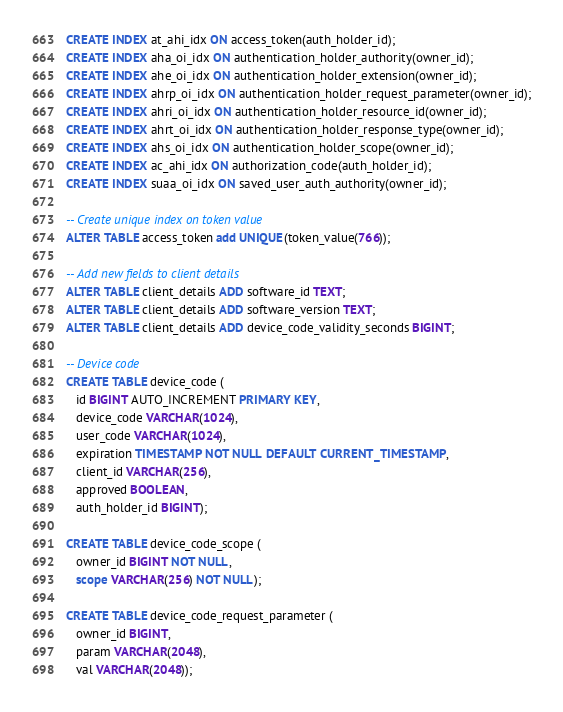Convert code to text. <code><loc_0><loc_0><loc_500><loc_500><_SQL_>CREATE INDEX at_ahi_idx ON access_token(auth_holder_id);
CREATE INDEX aha_oi_idx ON authentication_holder_authority(owner_id);
CREATE INDEX ahe_oi_idx ON authentication_holder_extension(owner_id);
CREATE INDEX ahrp_oi_idx ON authentication_holder_request_parameter(owner_id);
CREATE INDEX ahri_oi_idx ON authentication_holder_resource_id(owner_id);
CREATE INDEX ahrt_oi_idx ON authentication_holder_response_type(owner_id);
CREATE INDEX ahs_oi_idx ON authentication_holder_scope(owner_id);
CREATE INDEX ac_ahi_idx ON authorization_code(auth_holder_id);
CREATE INDEX suaa_oi_idx ON saved_user_auth_authority(owner_id);

-- Create unique index on token value
ALTER TABLE access_token add UNIQUE(token_value(766));

-- Add new fields to client details
ALTER TABLE client_details ADD software_id TEXT;
ALTER TABLE client_details ADD software_version TEXT;
ALTER TABLE client_details ADD device_code_validity_seconds BIGINT;

-- Device code
CREATE TABLE device_code (
   id BIGINT AUTO_INCREMENT PRIMARY KEY,
   device_code VARCHAR(1024),
   user_code VARCHAR(1024),
   expiration TIMESTAMP NOT NULL DEFAULT CURRENT_TIMESTAMP,
   client_id VARCHAR(256),
   approved BOOLEAN,
   auth_holder_id BIGINT);
   
CREATE TABLE device_code_scope (
   owner_id BIGINT NOT NULL,
   scope VARCHAR(256) NOT NULL);
 
CREATE TABLE device_code_request_parameter (
   owner_id BIGINT,
   param VARCHAR(2048),
   val VARCHAR(2048));
</code> 